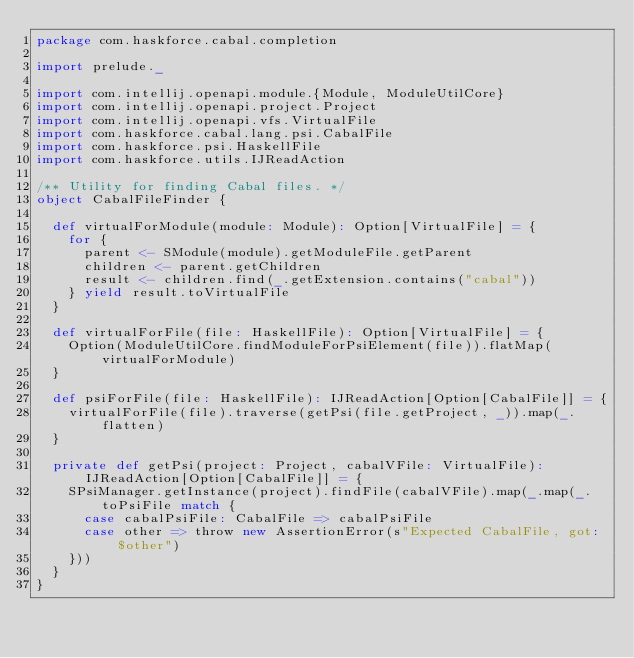<code> <loc_0><loc_0><loc_500><loc_500><_Scala_>package com.haskforce.cabal.completion

import prelude._

import com.intellij.openapi.module.{Module, ModuleUtilCore}
import com.intellij.openapi.project.Project
import com.intellij.openapi.vfs.VirtualFile
import com.haskforce.cabal.lang.psi.CabalFile
import com.haskforce.psi.HaskellFile
import com.haskforce.utils.IJReadAction

/** Utility for finding Cabal files. */
object CabalFileFinder {

  def virtualForModule(module: Module): Option[VirtualFile] = {
    for {
      parent <- SModule(module).getModuleFile.getParent
      children <- parent.getChildren
      result <- children.find(_.getExtension.contains("cabal"))
    } yield result.toVirtualFile
  }

  def virtualForFile(file: HaskellFile): Option[VirtualFile] = {
    Option(ModuleUtilCore.findModuleForPsiElement(file)).flatMap(virtualForModule)
  }

  def psiForFile(file: HaskellFile): IJReadAction[Option[CabalFile]] = {
    virtualForFile(file).traverse(getPsi(file.getProject, _)).map(_.flatten)
  }

  private def getPsi(project: Project, cabalVFile: VirtualFile): IJReadAction[Option[CabalFile]] = {
    SPsiManager.getInstance(project).findFile(cabalVFile).map(_.map(_.toPsiFile match {
      case cabalPsiFile: CabalFile => cabalPsiFile
      case other => throw new AssertionError(s"Expected CabalFile, got: $other")
    }))
  }
}
</code> 